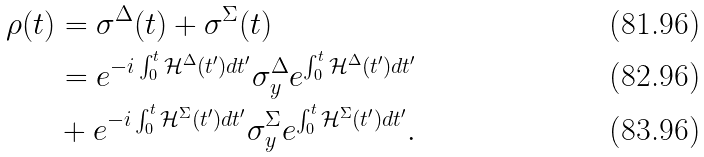Convert formula to latex. <formula><loc_0><loc_0><loc_500><loc_500>\rho ( t ) & = \sigma ^ { \Delta } ( t ) + \sigma ^ { \Sigma } ( t ) \\ & = e ^ { - i \int _ { 0 } ^ { t } \mathcal { H } ^ { \Delta } ( t ^ { \prime } ) d t ^ { \prime } } \sigma _ { y } ^ { \Delta } e ^ { \int _ { 0 } ^ { t } \mathcal { H } ^ { \Delta } ( t ^ { \prime } ) d t ^ { \prime } } \\ & + e ^ { - i \int _ { 0 } ^ { t } \mathcal { H } ^ { \Sigma } ( t ^ { \prime } ) d t ^ { \prime } } \sigma _ { y } ^ { \Sigma } e ^ { \int _ { 0 } ^ { t } \mathcal { H } ^ { \Sigma } ( t ^ { \prime } ) d t ^ { \prime } } .</formula> 